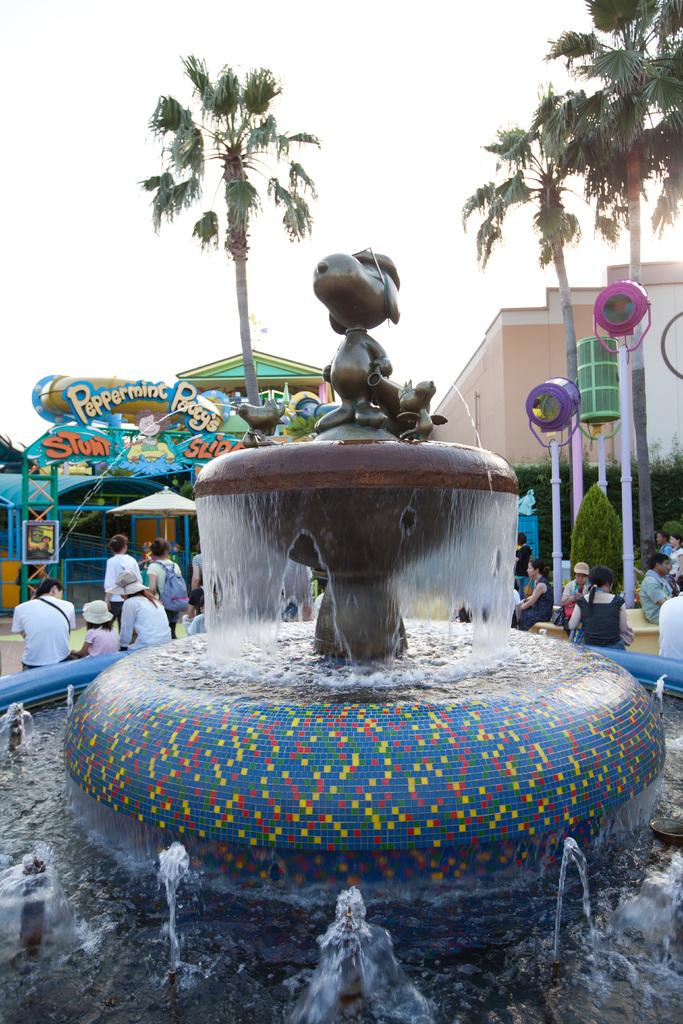What are the people in the image doing? The persons in the image are sitting beside the fountain. What can be seen on the right side of the image? There is a building and trees on the right side of the image. What is visible at the top of the image? The sky is visible at the top of the image. How many wristwatches are visible on the persons sitting beside the fountain? There is no mention of wristwatches in the image, so it is impossible to determine how many are visible. What type of growth can be seen on the trees in the image? There is no information about the trees' growth in the image, only that they are present on the right side. 